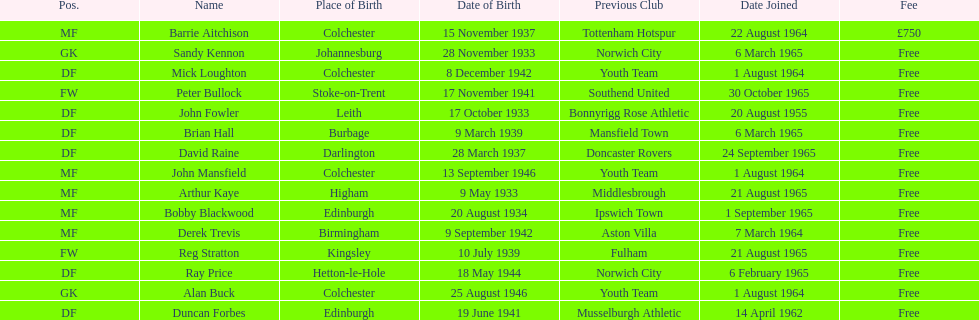When did alan buck join the colchester united f.c. in 1965-66? 1 August 1964. When did the last player to join? Peter Bullock. What date did the first player join? 20 August 1955. 